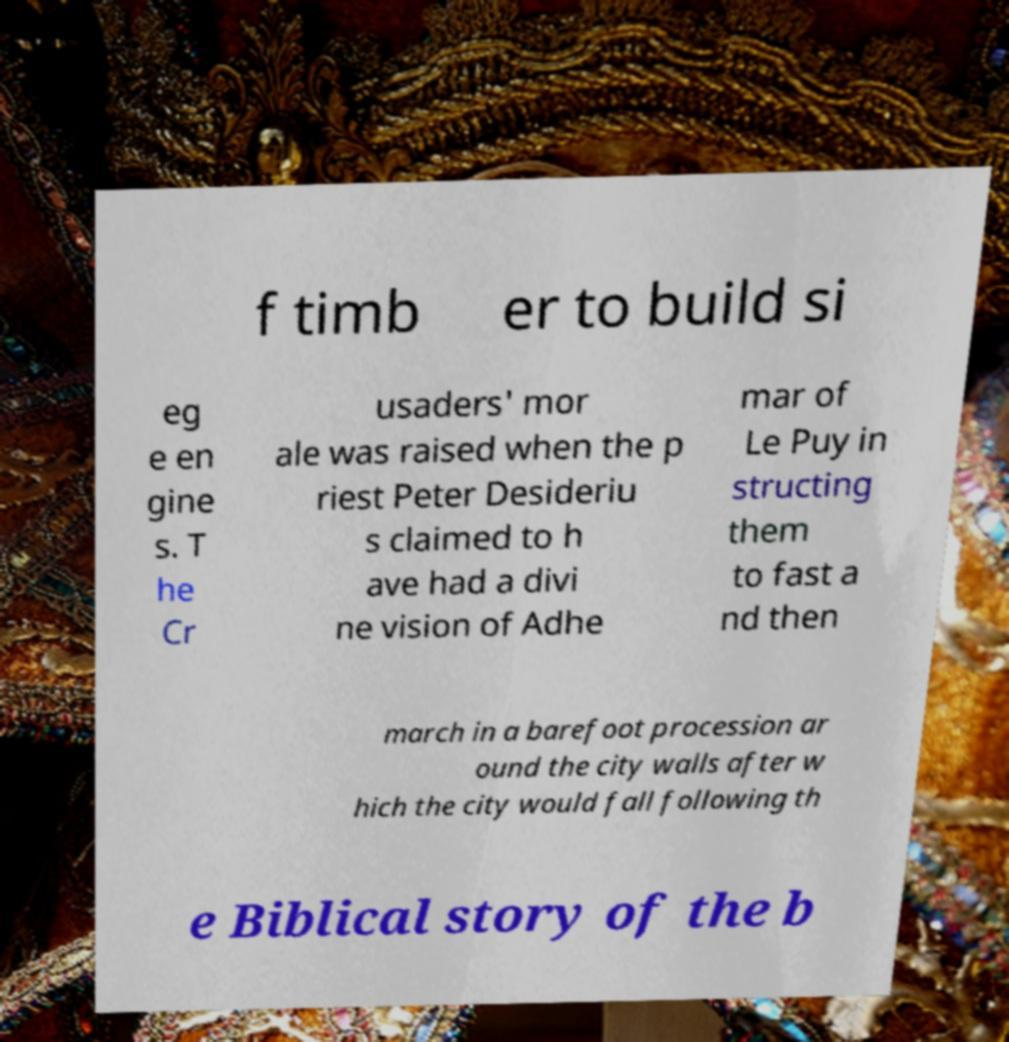Can you accurately transcribe the text from the provided image for me? f timb er to build si eg e en gine s. T he Cr usaders' mor ale was raised when the p riest Peter Desideriu s claimed to h ave had a divi ne vision of Adhe mar of Le Puy in structing them to fast a nd then march in a barefoot procession ar ound the city walls after w hich the city would fall following th e Biblical story of the b 